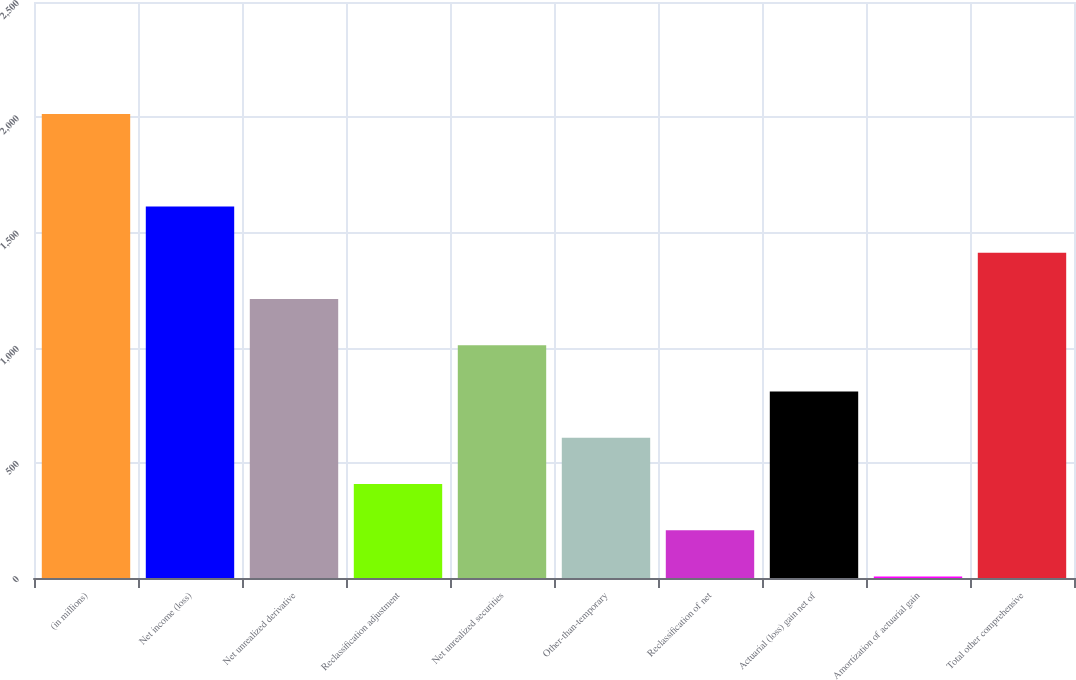<chart> <loc_0><loc_0><loc_500><loc_500><bar_chart><fcel>(in millions)<fcel>Net income (loss)<fcel>Net unrealized derivative<fcel>Reclassification adjustment<fcel>Net unrealized securities<fcel>Other-than-temporary<fcel>Reclassification of net<fcel>Actuarial (loss) gain net of<fcel>Amortization of actuarial gain<fcel>Total other comprehensive<nl><fcel>2014<fcel>1612.6<fcel>1211.2<fcel>408.4<fcel>1010.5<fcel>609.1<fcel>207.7<fcel>809.8<fcel>7<fcel>1411.9<nl></chart> 